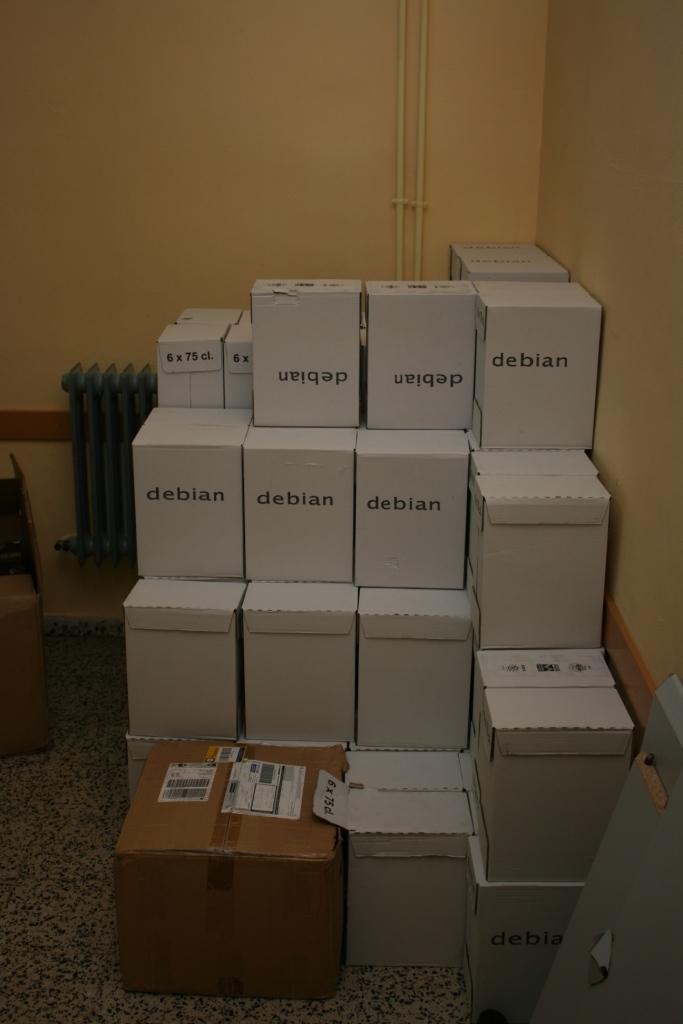<image>
Share a concise interpretation of the image provided. The white boxes are labeled Debian in the room. 